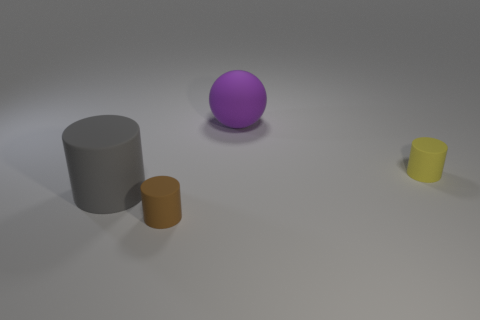Subtract all yellow cylinders. How many cylinders are left? 2 Subtract all gray cylinders. How many cylinders are left? 2 Subtract 1 cylinders. How many cylinders are left? 2 Add 1 small things. How many objects exist? 5 Subtract all spheres. How many objects are left? 3 Add 3 small yellow cylinders. How many small yellow cylinders are left? 4 Add 4 gray things. How many gray things exist? 5 Subtract 1 purple balls. How many objects are left? 3 Subtract all red cylinders. Subtract all red balls. How many cylinders are left? 3 Subtract all brown things. Subtract all large blue metal balls. How many objects are left? 3 